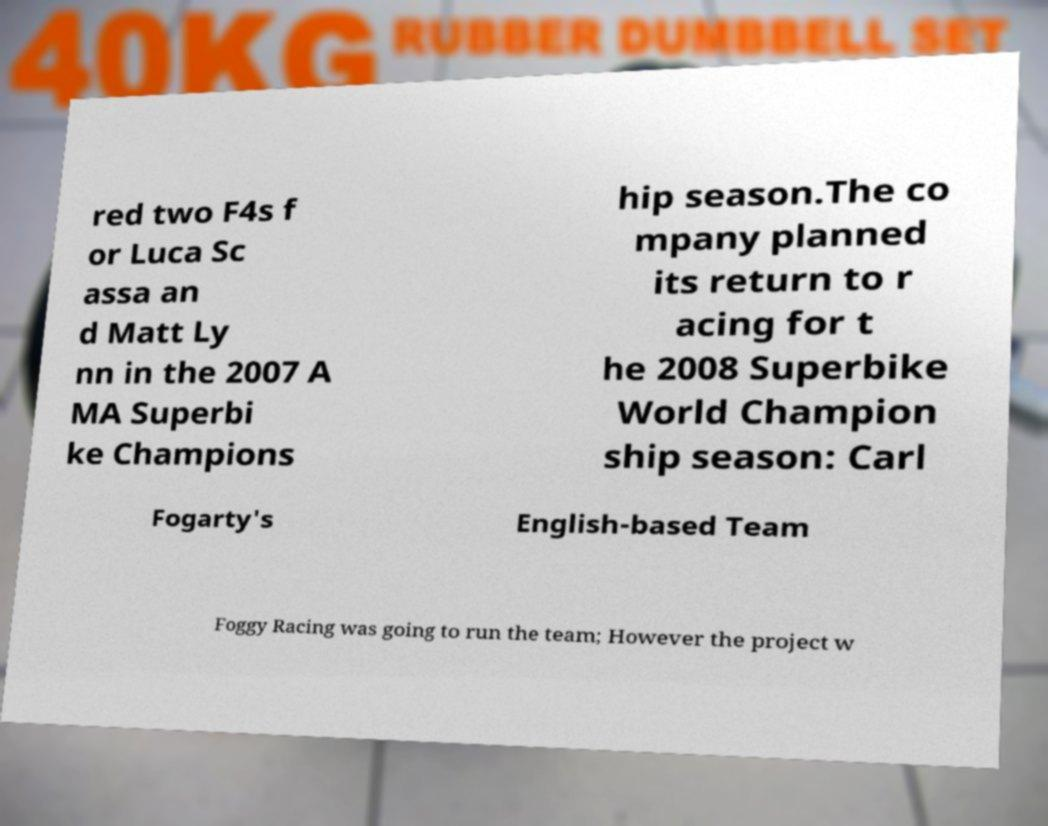Please read and relay the text visible in this image. What does it say? red two F4s f or Luca Sc assa an d Matt Ly nn in the 2007 A MA Superbi ke Champions hip season.The co mpany planned its return to r acing for t he 2008 Superbike World Champion ship season: Carl Fogarty's English-based Team Foggy Racing was going to run the team; However the project w 